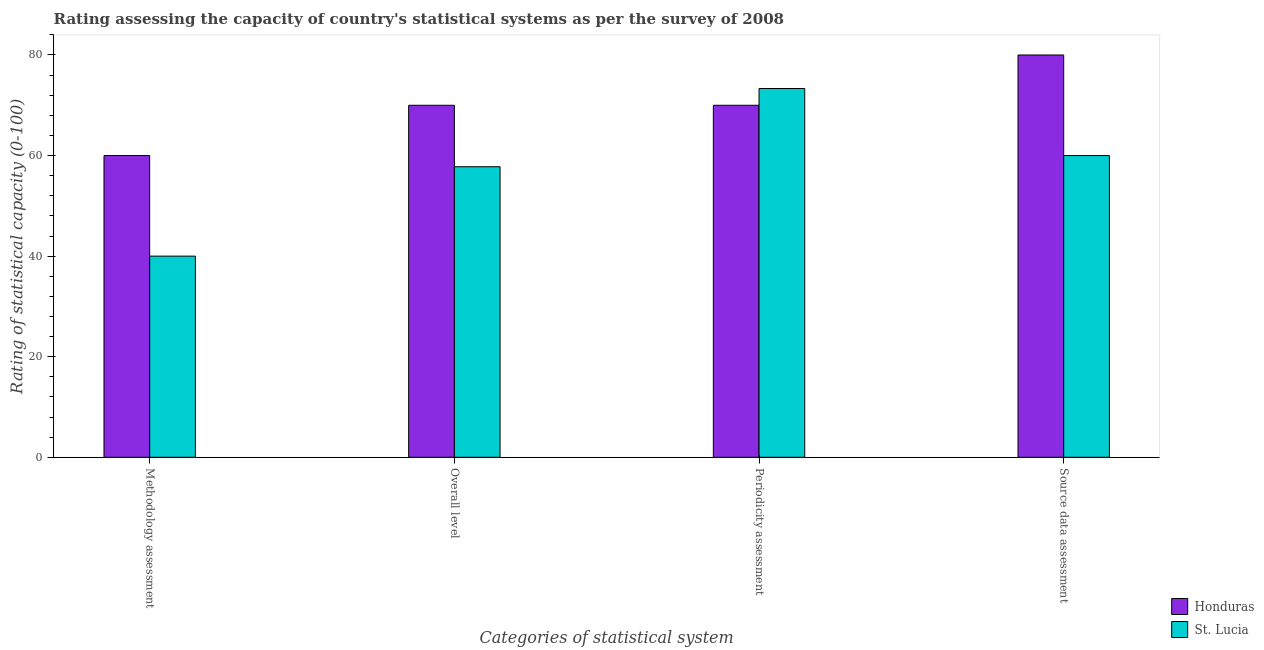How many groups of bars are there?
Keep it short and to the point. 4. Are the number of bars per tick equal to the number of legend labels?
Your answer should be very brief. Yes. How many bars are there on the 4th tick from the right?
Make the answer very short. 2. What is the label of the 2nd group of bars from the left?
Provide a succinct answer. Overall level. What is the methodology assessment rating in St. Lucia?
Make the answer very short. 40. Across all countries, what is the maximum overall level rating?
Your response must be concise. 70. Across all countries, what is the minimum source data assessment rating?
Your response must be concise. 60. In which country was the overall level rating maximum?
Your response must be concise. Honduras. In which country was the periodicity assessment rating minimum?
Your answer should be very brief. Honduras. What is the total source data assessment rating in the graph?
Provide a short and direct response. 140. What is the difference between the source data assessment rating in Honduras and that in St. Lucia?
Keep it short and to the point. 20. What is the difference between the methodology assessment rating in Honduras and the overall level rating in St. Lucia?
Give a very brief answer. 2.22. What is the average overall level rating per country?
Keep it short and to the point. 63.89. What is the difference between the methodology assessment rating and periodicity assessment rating in St. Lucia?
Provide a short and direct response. -33.33. In how many countries, is the source data assessment rating greater than 24 ?
Provide a succinct answer. 2. What is the ratio of the overall level rating in St. Lucia to that in Honduras?
Your answer should be compact. 0.83. Is the source data assessment rating in Honduras less than that in St. Lucia?
Keep it short and to the point. No. What is the difference between the highest and the second highest methodology assessment rating?
Provide a short and direct response. 20. What is the difference between the highest and the lowest periodicity assessment rating?
Offer a very short reply. 3.33. Is it the case that in every country, the sum of the overall level rating and source data assessment rating is greater than the sum of periodicity assessment rating and methodology assessment rating?
Ensure brevity in your answer.  No. What does the 2nd bar from the left in Methodology assessment represents?
Keep it short and to the point. St. Lucia. What does the 1st bar from the right in Methodology assessment represents?
Provide a short and direct response. St. Lucia. Are all the bars in the graph horizontal?
Your answer should be very brief. No. How many countries are there in the graph?
Give a very brief answer. 2. Does the graph contain any zero values?
Provide a succinct answer. No. Where does the legend appear in the graph?
Offer a terse response. Bottom right. How many legend labels are there?
Provide a succinct answer. 2. How are the legend labels stacked?
Your response must be concise. Vertical. What is the title of the graph?
Provide a succinct answer. Rating assessing the capacity of country's statistical systems as per the survey of 2008 . Does "New Zealand" appear as one of the legend labels in the graph?
Offer a very short reply. No. What is the label or title of the X-axis?
Offer a very short reply. Categories of statistical system. What is the label or title of the Y-axis?
Your answer should be compact. Rating of statistical capacity (0-100). What is the Rating of statistical capacity (0-100) in Honduras in Methodology assessment?
Provide a short and direct response. 60. What is the Rating of statistical capacity (0-100) of Honduras in Overall level?
Offer a very short reply. 70. What is the Rating of statistical capacity (0-100) of St. Lucia in Overall level?
Your answer should be very brief. 57.78. What is the Rating of statistical capacity (0-100) in St. Lucia in Periodicity assessment?
Offer a terse response. 73.33. What is the Rating of statistical capacity (0-100) in Honduras in Source data assessment?
Provide a short and direct response. 80. What is the Rating of statistical capacity (0-100) of St. Lucia in Source data assessment?
Offer a terse response. 60. Across all Categories of statistical system, what is the maximum Rating of statistical capacity (0-100) in Honduras?
Provide a short and direct response. 80. Across all Categories of statistical system, what is the maximum Rating of statistical capacity (0-100) in St. Lucia?
Offer a very short reply. 73.33. Across all Categories of statistical system, what is the minimum Rating of statistical capacity (0-100) in St. Lucia?
Provide a succinct answer. 40. What is the total Rating of statistical capacity (0-100) in Honduras in the graph?
Offer a very short reply. 280. What is the total Rating of statistical capacity (0-100) of St. Lucia in the graph?
Give a very brief answer. 231.11. What is the difference between the Rating of statistical capacity (0-100) in St. Lucia in Methodology assessment and that in Overall level?
Provide a succinct answer. -17.78. What is the difference between the Rating of statistical capacity (0-100) of Honduras in Methodology assessment and that in Periodicity assessment?
Offer a terse response. -10. What is the difference between the Rating of statistical capacity (0-100) in St. Lucia in Methodology assessment and that in Periodicity assessment?
Provide a succinct answer. -33.33. What is the difference between the Rating of statistical capacity (0-100) of Honduras in Methodology assessment and that in Source data assessment?
Your answer should be very brief. -20. What is the difference between the Rating of statistical capacity (0-100) in St. Lucia in Methodology assessment and that in Source data assessment?
Your answer should be very brief. -20. What is the difference between the Rating of statistical capacity (0-100) of Honduras in Overall level and that in Periodicity assessment?
Your answer should be very brief. 0. What is the difference between the Rating of statistical capacity (0-100) of St. Lucia in Overall level and that in Periodicity assessment?
Give a very brief answer. -15.56. What is the difference between the Rating of statistical capacity (0-100) of Honduras in Overall level and that in Source data assessment?
Ensure brevity in your answer.  -10. What is the difference between the Rating of statistical capacity (0-100) of St. Lucia in Overall level and that in Source data assessment?
Make the answer very short. -2.22. What is the difference between the Rating of statistical capacity (0-100) in St. Lucia in Periodicity assessment and that in Source data assessment?
Your response must be concise. 13.33. What is the difference between the Rating of statistical capacity (0-100) of Honduras in Methodology assessment and the Rating of statistical capacity (0-100) of St. Lucia in Overall level?
Offer a very short reply. 2.22. What is the difference between the Rating of statistical capacity (0-100) in Honduras in Methodology assessment and the Rating of statistical capacity (0-100) in St. Lucia in Periodicity assessment?
Your answer should be compact. -13.33. What is the difference between the Rating of statistical capacity (0-100) of Honduras in Overall level and the Rating of statistical capacity (0-100) of St. Lucia in Periodicity assessment?
Offer a terse response. -3.33. What is the difference between the Rating of statistical capacity (0-100) of Honduras in Overall level and the Rating of statistical capacity (0-100) of St. Lucia in Source data assessment?
Make the answer very short. 10. What is the difference between the Rating of statistical capacity (0-100) in Honduras in Periodicity assessment and the Rating of statistical capacity (0-100) in St. Lucia in Source data assessment?
Keep it short and to the point. 10. What is the average Rating of statistical capacity (0-100) in Honduras per Categories of statistical system?
Your response must be concise. 70. What is the average Rating of statistical capacity (0-100) of St. Lucia per Categories of statistical system?
Ensure brevity in your answer.  57.78. What is the difference between the Rating of statistical capacity (0-100) of Honduras and Rating of statistical capacity (0-100) of St. Lucia in Methodology assessment?
Ensure brevity in your answer.  20. What is the difference between the Rating of statistical capacity (0-100) of Honduras and Rating of statistical capacity (0-100) of St. Lucia in Overall level?
Provide a succinct answer. 12.22. What is the difference between the Rating of statistical capacity (0-100) in Honduras and Rating of statistical capacity (0-100) in St. Lucia in Periodicity assessment?
Make the answer very short. -3.33. What is the ratio of the Rating of statistical capacity (0-100) of Honduras in Methodology assessment to that in Overall level?
Your answer should be very brief. 0.86. What is the ratio of the Rating of statistical capacity (0-100) in St. Lucia in Methodology assessment to that in Overall level?
Make the answer very short. 0.69. What is the ratio of the Rating of statistical capacity (0-100) in St. Lucia in Methodology assessment to that in Periodicity assessment?
Make the answer very short. 0.55. What is the ratio of the Rating of statistical capacity (0-100) of Honduras in Overall level to that in Periodicity assessment?
Provide a short and direct response. 1. What is the ratio of the Rating of statistical capacity (0-100) in St. Lucia in Overall level to that in Periodicity assessment?
Provide a short and direct response. 0.79. What is the ratio of the Rating of statistical capacity (0-100) in Honduras in Overall level to that in Source data assessment?
Provide a succinct answer. 0.88. What is the ratio of the Rating of statistical capacity (0-100) in St. Lucia in Overall level to that in Source data assessment?
Give a very brief answer. 0.96. What is the ratio of the Rating of statistical capacity (0-100) of Honduras in Periodicity assessment to that in Source data assessment?
Offer a very short reply. 0.88. What is the ratio of the Rating of statistical capacity (0-100) of St. Lucia in Periodicity assessment to that in Source data assessment?
Make the answer very short. 1.22. What is the difference between the highest and the second highest Rating of statistical capacity (0-100) in Honduras?
Provide a succinct answer. 10. What is the difference between the highest and the second highest Rating of statistical capacity (0-100) of St. Lucia?
Provide a succinct answer. 13.33. What is the difference between the highest and the lowest Rating of statistical capacity (0-100) in Honduras?
Provide a short and direct response. 20. What is the difference between the highest and the lowest Rating of statistical capacity (0-100) of St. Lucia?
Offer a very short reply. 33.33. 